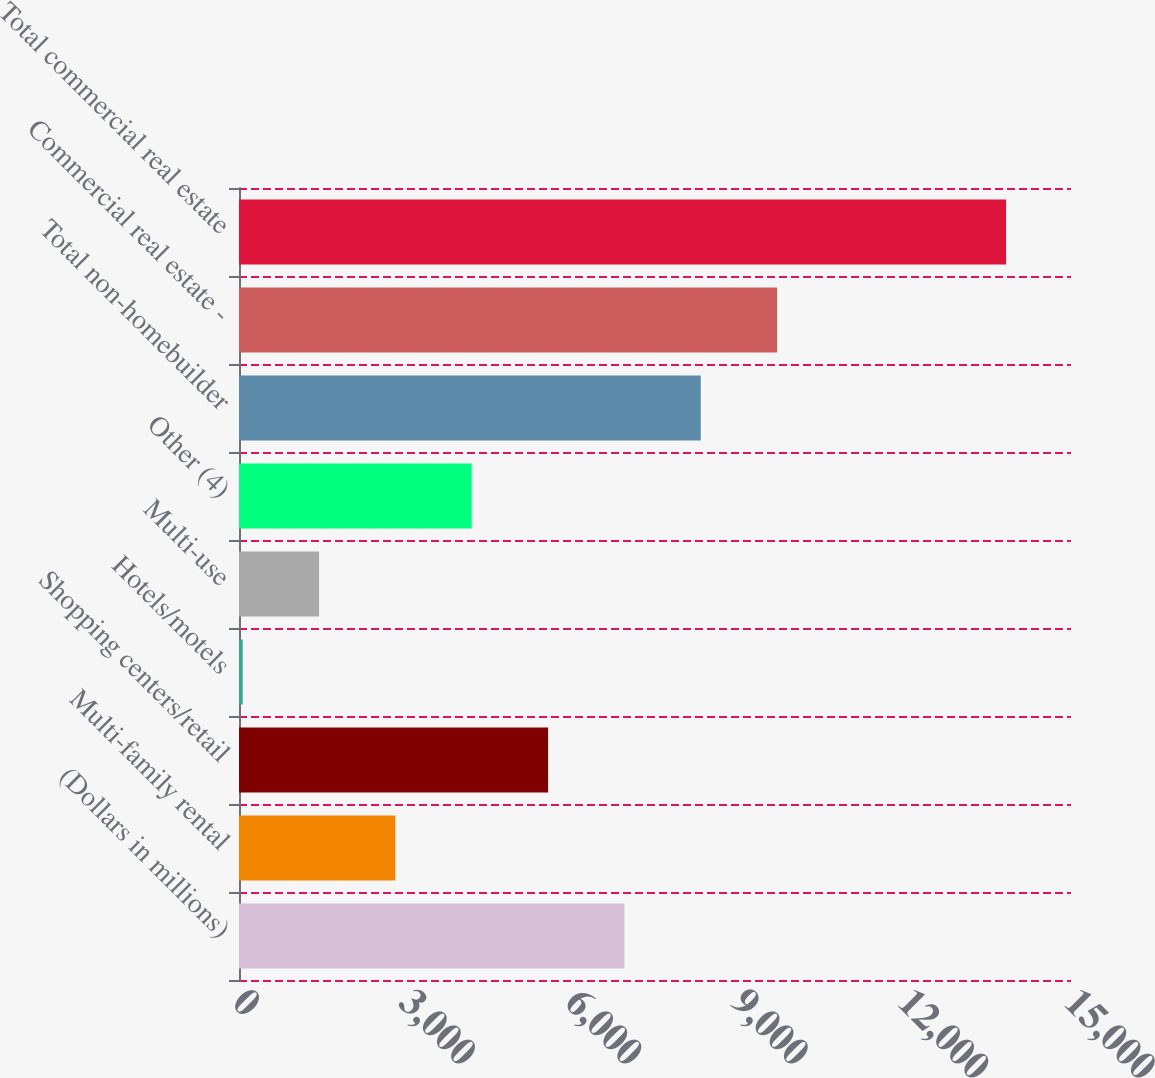Convert chart to OTSL. <chart><loc_0><loc_0><loc_500><loc_500><bar_chart><fcel>(Dollars in millions)<fcel>Multi-family rental<fcel>Shopping centers/retail<fcel>Hotels/motels<fcel>Multi-use<fcel>Other (4)<fcel>Total non-homebuilder<fcel>Commercial real estate -<fcel>Total commercial real estate<nl><fcel>6948.5<fcel>2819.6<fcel>5572.2<fcel>67<fcel>1443.3<fcel>4195.9<fcel>8324.8<fcel>9701.1<fcel>13830<nl></chart> 